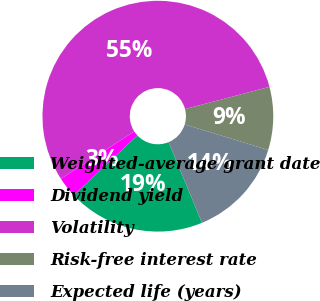<chart> <loc_0><loc_0><loc_500><loc_500><pie_chart><fcel>Weighted-average grant date<fcel>Dividend yield<fcel>Volatility<fcel>Risk-free interest rate<fcel>Expected life (years)<nl><fcel>19.25%<fcel>2.88%<fcel>55.02%<fcel>8.82%<fcel>14.03%<nl></chart> 